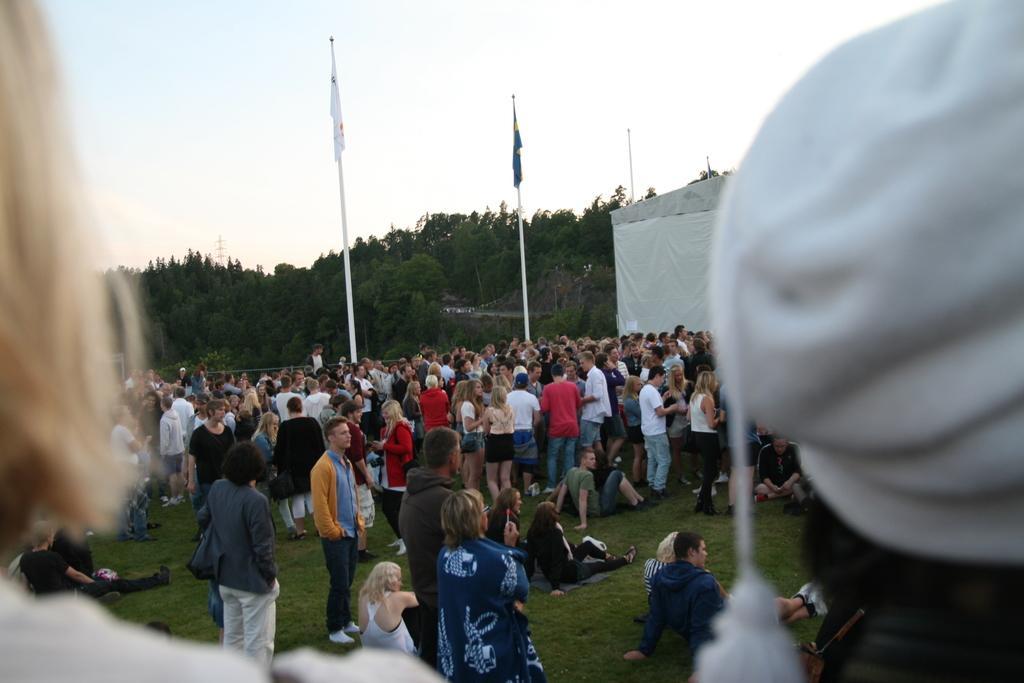How would you summarize this image in a sentence or two? This is an outside view. On the ground, I can see the grass. Here I can see a crowd of people standing on the ground. In the background there are few flags and trees. On the right side, I can see a white color cap. On the left side, I can see a person's head. At the top of the image I can see the sky. 